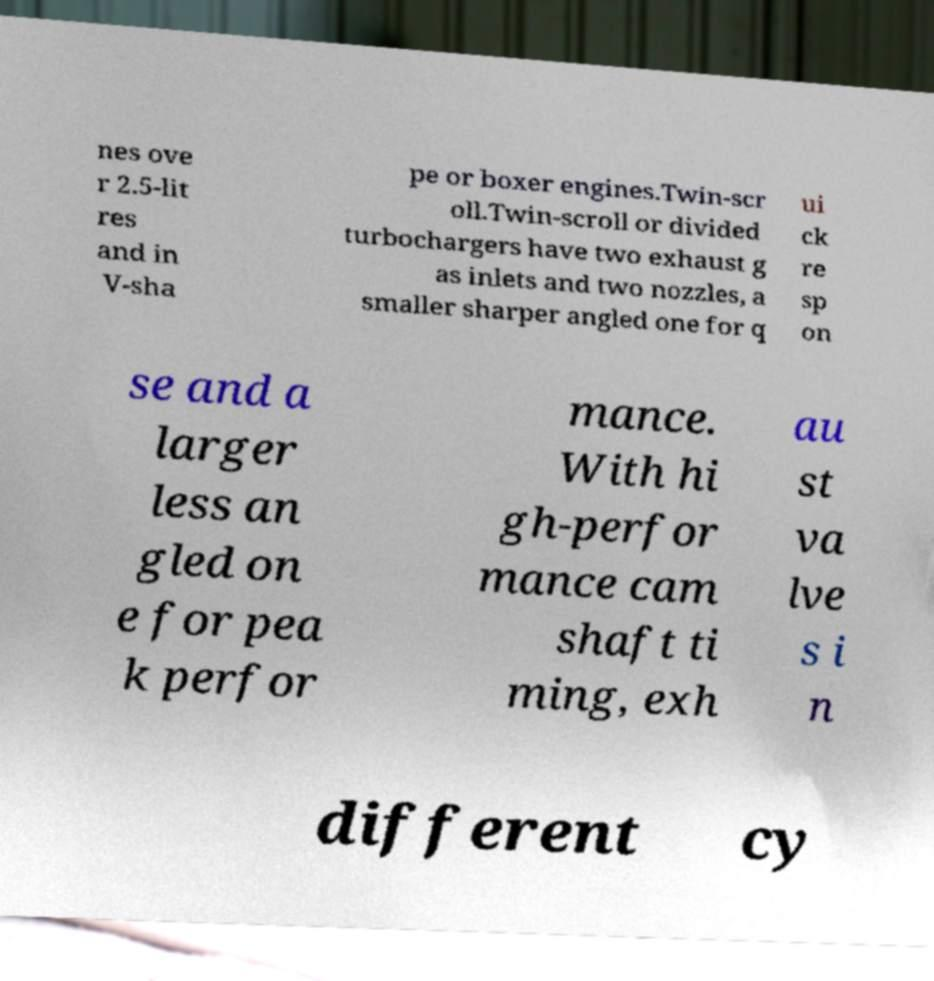Could you assist in decoding the text presented in this image and type it out clearly? nes ove r 2.5-lit res and in V-sha pe or boxer engines.Twin-scr oll.Twin-scroll or divided turbochargers have two exhaust g as inlets and two nozzles, a smaller sharper angled one for q ui ck re sp on se and a larger less an gled on e for pea k perfor mance. With hi gh-perfor mance cam shaft ti ming, exh au st va lve s i n different cy 